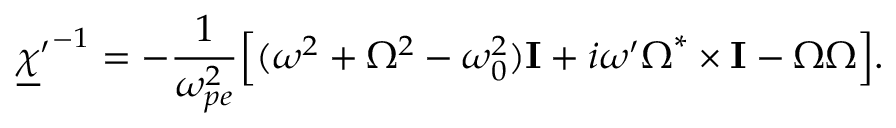Convert formula to latex. <formula><loc_0><loc_0><loc_500><loc_500>{ \underline { \chi } ^ { \prime } } ^ { - 1 } = - \frac { 1 } { \omega _ { p e } ^ { 2 } } \left [ ( \omega ^ { 2 } + \Omega ^ { 2 } - \omega _ { 0 } ^ { 2 } ) { \mathbf I } + i \omega ^ { \prime } \boldsymbol \Omega ^ { * } \times { \mathbf I } - \boldsymbol \Omega \boldsymbol \Omega \right ] .</formula> 